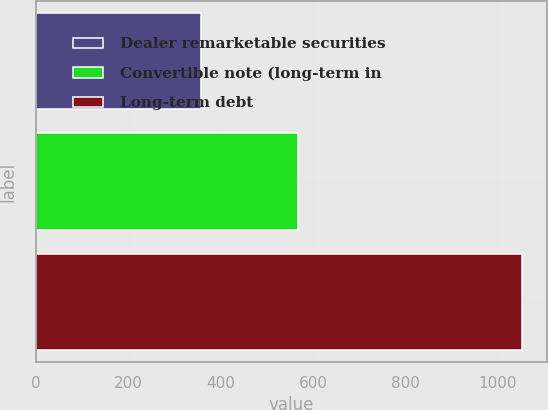Convert chart to OTSL. <chart><loc_0><loc_0><loc_500><loc_500><bar_chart><fcel>Dealer remarketable securities<fcel>Convertible note (long-term in<fcel>Long-term debt<nl><fcel>358<fcel>568<fcel>1054<nl></chart> 